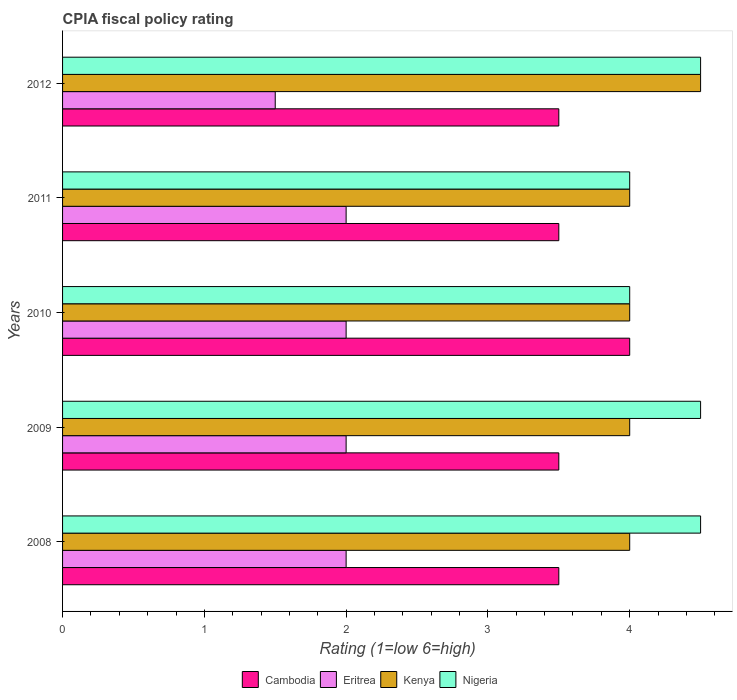How many different coloured bars are there?
Give a very brief answer. 4. How many groups of bars are there?
Offer a very short reply. 5. How many bars are there on the 4th tick from the top?
Give a very brief answer. 4. What is the label of the 4th group of bars from the top?
Offer a very short reply. 2009. Across all years, what is the maximum CPIA rating in Kenya?
Give a very brief answer. 4.5. What is the total CPIA rating in Cambodia in the graph?
Your answer should be very brief. 18. What is the difference between the CPIA rating in Eritrea in 2009 and the CPIA rating in Kenya in 2008?
Your answer should be compact. -2. What is the average CPIA rating in Eritrea per year?
Your answer should be compact. 1.9. In how many years, is the CPIA rating in Nigeria greater than 0.2 ?
Offer a very short reply. 5. What is the ratio of the CPIA rating in Eritrea in 2009 to that in 2010?
Provide a short and direct response. 1. Is the difference between the CPIA rating in Nigeria in 2010 and 2011 greater than the difference between the CPIA rating in Kenya in 2010 and 2011?
Your answer should be compact. No. What is the difference between the highest and the lowest CPIA rating in Nigeria?
Offer a very short reply. 0.5. What does the 1st bar from the top in 2012 represents?
Your answer should be very brief. Nigeria. What does the 4th bar from the bottom in 2012 represents?
Offer a terse response. Nigeria. Is it the case that in every year, the sum of the CPIA rating in Nigeria and CPIA rating in Kenya is greater than the CPIA rating in Eritrea?
Offer a terse response. Yes. Are all the bars in the graph horizontal?
Your answer should be compact. Yes. What is the difference between two consecutive major ticks on the X-axis?
Offer a terse response. 1. Are the values on the major ticks of X-axis written in scientific E-notation?
Give a very brief answer. No. Does the graph contain grids?
Provide a succinct answer. No. Where does the legend appear in the graph?
Offer a very short reply. Bottom center. How many legend labels are there?
Your answer should be very brief. 4. What is the title of the graph?
Provide a succinct answer. CPIA fiscal policy rating. Does "Mali" appear as one of the legend labels in the graph?
Make the answer very short. No. What is the label or title of the Y-axis?
Your answer should be very brief. Years. What is the Rating (1=low 6=high) of Cambodia in 2009?
Keep it short and to the point. 3.5. What is the Rating (1=low 6=high) of Eritrea in 2009?
Give a very brief answer. 2. What is the Rating (1=low 6=high) of Kenya in 2009?
Give a very brief answer. 4. What is the Rating (1=low 6=high) of Nigeria in 2009?
Keep it short and to the point. 4.5. What is the Rating (1=low 6=high) of Kenya in 2011?
Provide a short and direct response. 4. What is the Rating (1=low 6=high) of Cambodia in 2012?
Ensure brevity in your answer.  3.5. What is the Rating (1=low 6=high) in Eritrea in 2012?
Provide a succinct answer. 1.5. What is the Rating (1=low 6=high) of Kenya in 2012?
Your answer should be very brief. 4.5. What is the Rating (1=low 6=high) in Nigeria in 2012?
Give a very brief answer. 4.5. Across all years, what is the maximum Rating (1=low 6=high) of Kenya?
Offer a very short reply. 4.5. Across all years, what is the minimum Rating (1=low 6=high) in Eritrea?
Keep it short and to the point. 1.5. Across all years, what is the minimum Rating (1=low 6=high) in Nigeria?
Offer a terse response. 4. What is the total Rating (1=low 6=high) of Cambodia in the graph?
Offer a terse response. 18. What is the total Rating (1=low 6=high) in Eritrea in the graph?
Ensure brevity in your answer.  9.5. What is the total Rating (1=low 6=high) of Nigeria in the graph?
Offer a terse response. 21.5. What is the difference between the Rating (1=low 6=high) of Cambodia in 2008 and that in 2009?
Provide a short and direct response. 0. What is the difference between the Rating (1=low 6=high) in Eritrea in 2008 and that in 2009?
Make the answer very short. 0. What is the difference between the Rating (1=low 6=high) in Kenya in 2008 and that in 2009?
Ensure brevity in your answer.  0. What is the difference between the Rating (1=low 6=high) in Nigeria in 2008 and that in 2009?
Provide a short and direct response. 0. What is the difference between the Rating (1=low 6=high) of Nigeria in 2008 and that in 2010?
Offer a very short reply. 0.5. What is the difference between the Rating (1=low 6=high) of Eritrea in 2008 and that in 2011?
Ensure brevity in your answer.  0. What is the difference between the Rating (1=low 6=high) of Nigeria in 2008 and that in 2011?
Provide a short and direct response. 0.5. What is the difference between the Rating (1=low 6=high) of Cambodia in 2008 and that in 2012?
Ensure brevity in your answer.  0. What is the difference between the Rating (1=low 6=high) in Nigeria in 2008 and that in 2012?
Ensure brevity in your answer.  0. What is the difference between the Rating (1=low 6=high) of Cambodia in 2009 and that in 2010?
Make the answer very short. -0.5. What is the difference between the Rating (1=low 6=high) in Kenya in 2009 and that in 2011?
Keep it short and to the point. 0. What is the difference between the Rating (1=low 6=high) in Nigeria in 2009 and that in 2011?
Provide a succinct answer. 0.5. What is the difference between the Rating (1=low 6=high) of Cambodia in 2009 and that in 2012?
Make the answer very short. 0. What is the difference between the Rating (1=low 6=high) of Cambodia in 2010 and that in 2011?
Provide a short and direct response. 0.5. What is the difference between the Rating (1=low 6=high) of Nigeria in 2010 and that in 2011?
Ensure brevity in your answer.  0. What is the difference between the Rating (1=low 6=high) of Eritrea in 2010 and that in 2012?
Your answer should be compact. 0.5. What is the difference between the Rating (1=low 6=high) of Kenya in 2010 and that in 2012?
Your response must be concise. -0.5. What is the difference between the Rating (1=low 6=high) in Kenya in 2011 and that in 2012?
Offer a very short reply. -0.5. What is the difference between the Rating (1=low 6=high) in Cambodia in 2008 and the Rating (1=low 6=high) in Kenya in 2009?
Offer a very short reply. -0.5. What is the difference between the Rating (1=low 6=high) of Eritrea in 2008 and the Rating (1=low 6=high) of Kenya in 2009?
Your answer should be very brief. -2. What is the difference between the Rating (1=low 6=high) in Eritrea in 2008 and the Rating (1=low 6=high) in Nigeria in 2009?
Your answer should be very brief. -2.5. What is the difference between the Rating (1=low 6=high) in Kenya in 2008 and the Rating (1=low 6=high) in Nigeria in 2009?
Provide a short and direct response. -0.5. What is the difference between the Rating (1=low 6=high) of Eritrea in 2008 and the Rating (1=low 6=high) of Nigeria in 2010?
Keep it short and to the point. -2. What is the difference between the Rating (1=low 6=high) of Cambodia in 2008 and the Rating (1=low 6=high) of Kenya in 2011?
Make the answer very short. -0.5. What is the difference between the Rating (1=low 6=high) in Cambodia in 2008 and the Rating (1=low 6=high) in Nigeria in 2011?
Give a very brief answer. -0.5. What is the difference between the Rating (1=low 6=high) of Eritrea in 2008 and the Rating (1=low 6=high) of Kenya in 2011?
Provide a succinct answer. -2. What is the difference between the Rating (1=low 6=high) of Cambodia in 2008 and the Rating (1=low 6=high) of Kenya in 2012?
Offer a very short reply. -1. What is the difference between the Rating (1=low 6=high) of Cambodia in 2008 and the Rating (1=low 6=high) of Nigeria in 2012?
Make the answer very short. -1. What is the difference between the Rating (1=low 6=high) of Eritrea in 2008 and the Rating (1=low 6=high) of Nigeria in 2012?
Provide a short and direct response. -2.5. What is the difference between the Rating (1=low 6=high) in Kenya in 2008 and the Rating (1=low 6=high) in Nigeria in 2012?
Keep it short and to the point. -0.5. What is the difference between the Rating (1=low 6=high) in Cambodia in 2009 and the Rating (1=low 6=high) in Eritrea in 2010?
Offer a terse response. 1.5. What is the difference between the Rating (1=low 6=high) of Cambodia in 2009 and the Rating (1=low 6=high) of Kenya in 2010?
Your response must be concise. -0.5. What is the difference between the Rating (1=low 6=high) of Cambodia in 2009 and the Rating (1=low 6=high) of Nigeria in 2010?
Your response must be concise. -0.5. What is the difference between the Rating (1=low 6=high) of Eritrea in 2009 and the Rating (1=low 6=high) of Kenya in 2010?
Offer a terse response. -2. What is the difference between the Rating (1=low 6=high) of Eritrea in 2009 and the Rating (1=low 6=high) of Nigeria in 2010?
Offer a very short reply. -2. What is the difference between the Rating (1=low 6=high) of Cambodia in 2009 and the Rating (1=low 6=high) of Eritrea in 2011?
Provide a short and direct response. 1.5. What is the difference between the Rating (1=low 6=high) of Eritrea in 2009 and the Rating (1=low 6=high) of Kenya in 2011?
Make the answer very short. -2. What is the difference between the Rating (1=low 6=high) in Eritrea in 2009 and the Rating (1=low 6=high) in Nigeria in 2011?
Your answer should be very brief. -2. What is the difference between the Rating (1=low 6=high) of Cambodia in 2009 and the Rating (1=low 6=high) of Kenya in 2012?
Offer a terse response. -1. What is the difference between the Rating (1=low 6=high) in Cambodia in 2009 and the Rating (1=low 6=high) in Nigeria in 2012?
Make the answer very short. -1. What is the difference between the Rating (1=low 6=high) of Cambodia in 2010 and the Rating (1=low 6=high) of Kenya in 2011?
Offer a very short reply. 0. What is the difference between the Rating (1=low 6=high) of Cambodia in 2010 and the Rating (1=low 6=high) of Nigeria in 2011?
Ensure brevity in your answer.  0. What is the difference between the Rating (1=low 6=high) in Eritrea in 2010 and the Rating (1=low 6=high) in Nigeria in 2011?
Your response must be concise. -2. What is the difference between the Rating (1=low 6=high) in Cambodia in 2010 and the Rating (1=low 6=high) in Kenya in 2012?
Keep it short and to the point. -0.5. What is the difference between the Rating (1=low 6=high) of Cambodia in 2010 and the Rating (1=low 6=high) of Nigeria in 2012?
Your answer should be very brief. -0.5. What is the difference between the Rating (1=low 6=high) of Kenya in 2010 and the Rating (1=low 6=high) of Nigeria in 2012?
Provide a short and direct response. -0.5. What is the difference between the Rating (1=low 6=high) in Cambodia in 2011 and the Rating (1=low 6=high) in Eritrea in 2012?
Keep it short and to the point. 2. What is the difference between the Rating (1=low 6=high) in Cambodia in 2011 and the Rating (1=low 6=high) in Kenya in 2012?
Keep it short and to the point. -1. What is the difference between the Rating (1=low 6=high) of Cambodia in 2011 and the Rating (1=low 6=high) of Nigeria in 2012?
Offer a terse response. -1. What is the difference between the Rating (1=low 6=high) in Eritrea in 2011 and the Rating (1=low 6=high) in Kenya in 2012?
Keep it short and to the point. -2.5. What is the difference between the Rating (1=low 6=high) of Kenya in 2011 and the Rating (1=low 6=high) of Nigeria in 2012?
Your response must be concise. -0.5. What is the average Rating (1=low 6=high) of Cambodia per year?
Keep it short and to the point. 3.6. What is the average Rating (1=low 6=high) of Eritrea per year?
Provide a short and direct response. 1.9. What is the average Rating (1=low 6=high) in Kenya per year?
Offer a very short reply. 4.1. What is the average Rating (1=low 6=high) of Nigeria per year?
Your response must be concise. 4.3. In the year 2008, what is the difference between the Rating (1=low 6=high) of Cambodia and Rating (1=low 6=high) of Kenya?
Ensure brevity in your answer.  -0.5. In the year 2009, what is the difference between the Rating (1=low 6=high) in Cambodia and Rating (1=low 6=high) in Eritrea?
Give a very brief answer. 1.5. In the year 2009, what is the difference between the Rating (1=low 6=high) of Eritrea and Rating (1=low 6=high) of Nigeria?
Your answer should be compact. -2.5. In the year 2010, what is the difference between the Rating (1=low 6=high) in Cambodia and Rating (1=low 6=high) in Nigeria?
Your response must be concise. 0. In the year 2010, what is the difference between the Rating (1=low 6=high) in Eritrea and Rating (1=low 6=high) in Kenya?
Make the answer very short. -2. In the year 2011, what is the difference between the Rating (1=low 6=high) of Cambodia and Rating (1=low 6=high) of Eritrea?
Your response must be concise. 1.5. In the year 2011, what is the difference between the Rating (1=low 6=high) of Cambodia and Rating (1=low 6=high) of Nigeria?
Offer a very short reply. -0.5. In the year 2011, what is the difference between the Rating (1=low 6=high) of Eritrea and Rating (1=low 6=high) of Nigeria?
Your answer should be compact. -2. In the year 2012, what is the difference between the Rating (1=low 6=high) of Cambodia and Rating (1=low 6=high) of Eritrea?
Your answer should be compact. 2. In the year 2012, what is the difference between the Rating (1=low 6=high) of Cambodia and Rating (1=low 6=high) of Kenya?
Ensure brevity in your answer.  -1. In the year 2012, what is the difference between the Rating (1=low 6=high) in Eritrea and Rating (1=low 6=high) in Kenya?
Ensure brevity in your answer.  -3. In the year 2012, what is the difference between the Rating (1=low 6=high) in Kenya and Rating (1=low 6=high) in Nigeria?
Offer a terse response. 0. What is the ratio of the Rating (1=low 6=high) of Cambodia in 2008 to that in 2010?
Offer a terse response. 0.88. What is the ratio of the Rating (1=low 6=high) in Eritrea in 2008 to that in 2010?
Your response must be concise. 1. What is the ratio of the Rating (1=low 6=high) of Nigeria in 2008 to that in 2010?
Your response must be concise. 1.12. What is the ratio of the Rating (1=low 6=high) in Eritrea in 2008 to that in 2011?
Offer a terse response. 1. What is the ratio of the Rating (1=low 6=high) of Nigeria in 2008 to that in 2011?
Give a very brief answer. 1.12. What is the ratio of the Rating (1=low 6=high) in Cambodia in 2009 to that in 2010?
Offer a terse response. 0.88. What is the ratio of the Rating (1=low 6=high) in Eritrea in 2009 to that in 2010?
Provide a short and direct response. 1. What is the ratio of the Rating (1=low 6=high) of Kenya in 2009 to that in 2010?
Ensure brevity in your answer.  1. What is the ratio of the Rating (1=low 6=high) of Nigeria in 2009 to that in 2010?
Your answer should be compact. 1.12. What is the ratio of the Rating (1=low 6=high) of Eritrea in 2009 to that in 2011?
Your answer should be compact. 1. What is the ratio of the Rating (1=low 6=high) in Kenya in 2009 to that in 2011?
Ensure brevity in your answer.  1. What is the ratio of the Rating (1=low 6=high) of Nigeria in 2009 to that in 2011?
Keep it short and to the point. 1.12. What is the ratio of the Rating (1=low 6=high) of Eritrea in 2010 to that in 2011?
Give a very brief answer. 1. What is the ratio of the Rating (1=low 6=high) in Kenya in 2010 to that in 2011?
Make the answer very short. 1. What is the ratio of the Rating (1=low 6=high) in Nigeria in 2010 to that in 2011?
Your answer should be compact. 1. What is the ratio of the Rating (1=low 6=high) of Cambodia in 2010 to that in 2012?
Make the answer very short. 1.14. What is the ratio of the Rating (1=low 6=high) of Eritrea in 2010 to that in 2012?
Offer a terse response. 1.33. What is the ratio of the Rating (1=low 6=high) of Kenya in 2010 to that in 2012?
Provide a succinct answer. 0.89. What is the ratio of the Rating (1=low 6=high) in Kenya in 2011 to that in 2012?
Provide a short and direct response. 0.89. What is the ratio of the Rating (1=low 6=high) of Nigeria in 2011 to that in 2012?
Offer a terse response. 0.89. What is the difference between the highest and the second highest Rating (1=low 6=high) of Nigeria?
Offer a terse response. 0. What is the difference between the highest and the lowest Rating (1=low 6=high) of Kenya?
Your answer should be compact. 0.5. 